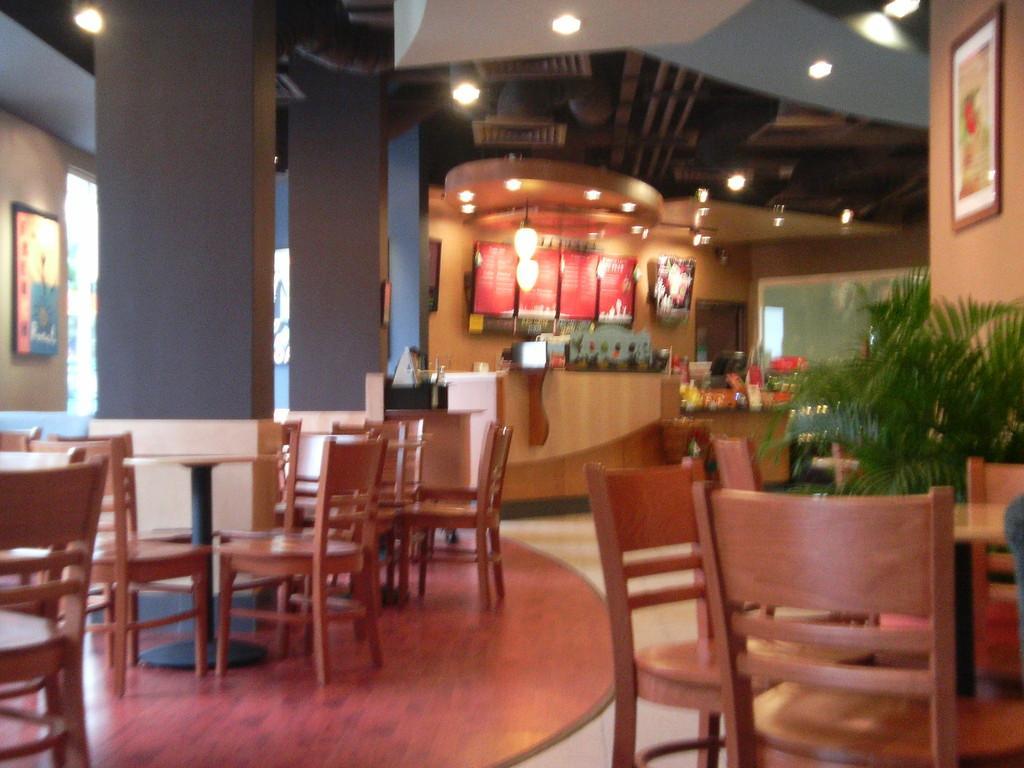Describe this image in one or two sentences. In this image we can see some chairs and tables on the floor. We can also see some pillars, a photo frame hanged to a wall and some plants. On the backside we can see a board and a roof with some ceiling lights. 